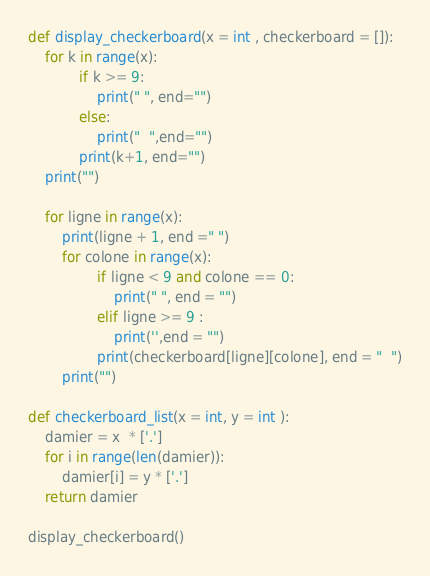Convert code to text. <code><loc_0><loc_0><loc_500><loc_500><_Python_>def display_checkerboard(x = int , checkerboard = []):
    for k in range(x):
            if k >= 9: 
                print(" ", end="")
            else: 
                print("  ",end="")
            print(k+1, end="")
    print("")

    for ligne in range(x):
        print(ligne + 1, end =" ")
        for colone in range(x):
                if ligne < 9 and colone == 0:
                    print(" ", end = "")
                elif ligne >= 9 :
                    print('',end = "") 
                print(checkerboard[ligne][colone], end = "  ")
        print("")

def checkerboard_list(x = int, y = int ):
    damier = x  * ['.']
    for i in range(len(damier)):
        damier[i] = y * ['.']
    return damier

display_checkerboard()

</code> 